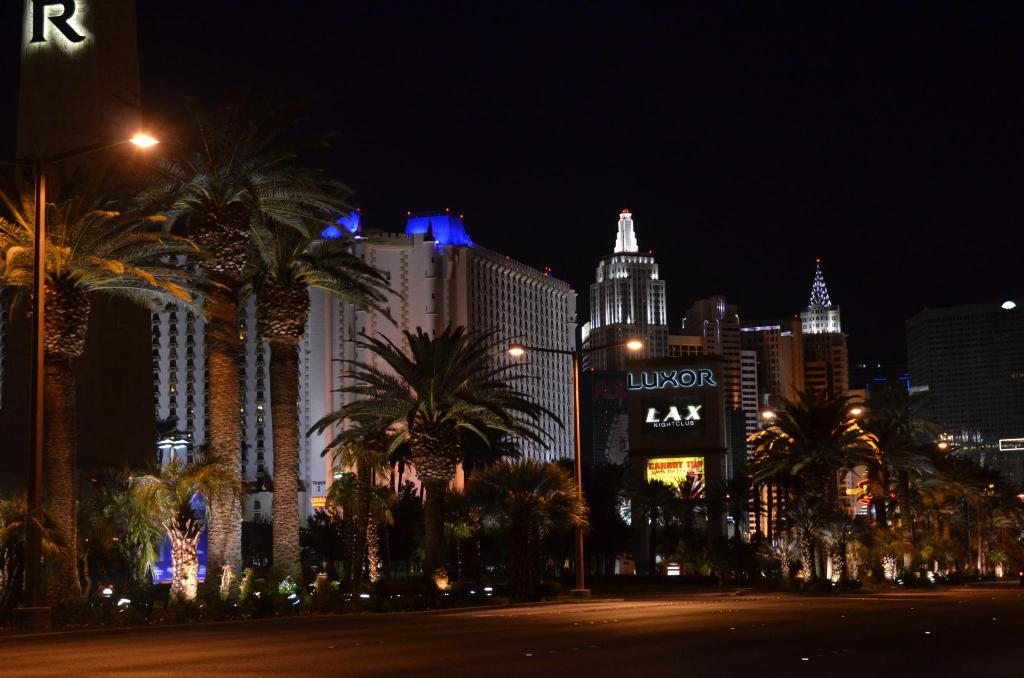What type of structures can be seen in the image? There are buildings in the image. What other objects can be seen in the image besides buildings? There are poles, lights, and trees visible in the image. What is the color of the background in the image? The background of the image is dark. What type of camera can be seen in the image? There is no camera present in the image. Who is the coach in the image? There is no coach present in the image. 